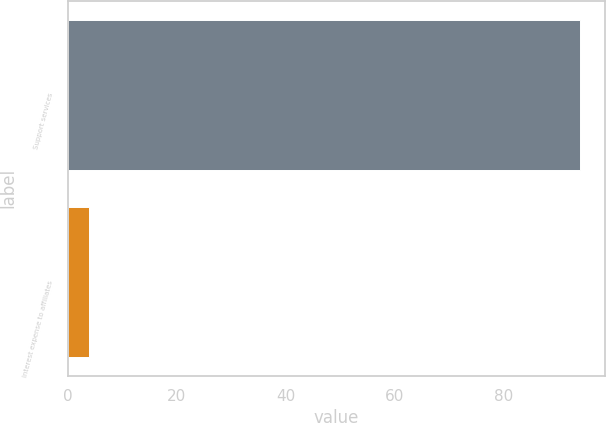Convert chart. <chart><loc_0><loc_0><loc_500><loc_500><bar_chart><fcel>Support services<fcel>Interest expense to affiliates<nl><fcel>94<fcel>4<nl></chart> 